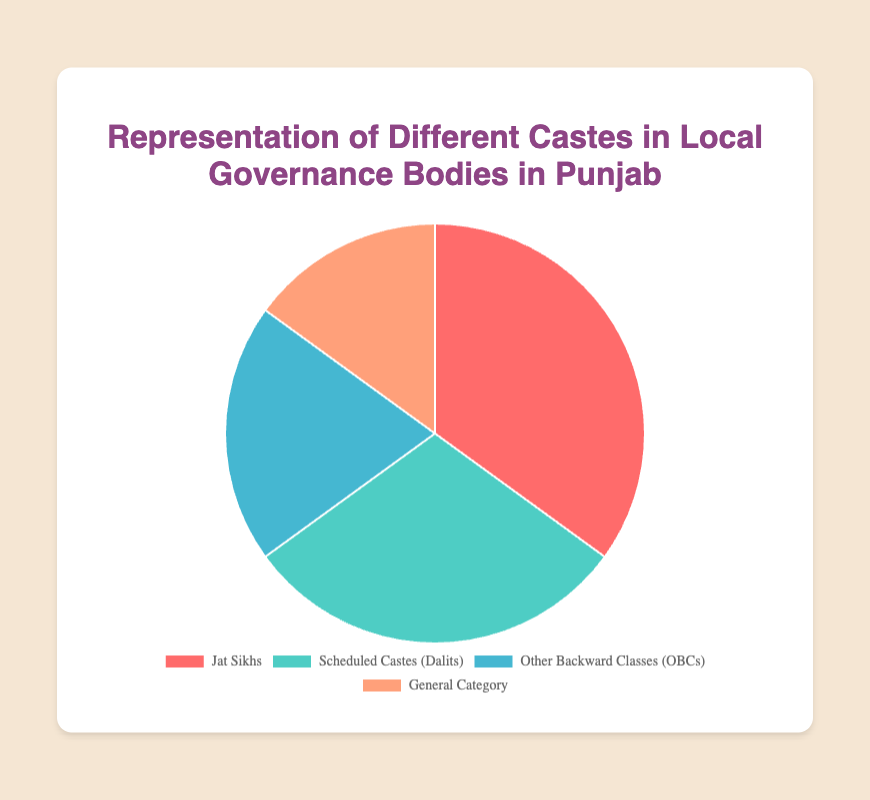What is the representation percentage of Scheduled Castes (Dalits) in local governance bodies? The figure shows that the representation of Scheduled Castes (Dalits) is 30%.
Answer: 30% Which caste has the highest representation in local governance bodies? The largest segment in the pie chart belongs to Jat Sikhs, indicating they have the highest representation.
Answer: Jat Sikhs What is the combined representation of Other Backward Classes (OBCs) and the General Category? The representation of OBCs is 20%, and the General Category is 15%. Summing these gives 20% + 15% = 35%.
Answer: 35% Which caste has the lowest representation, and what is that percentage? By observing the smallest segment in the pie chart, the General Category has the lowest representation at 15%.
Answer: General Category, 15% Is the representation of Scheduled Castes (Dalits) more or less than the combined representation of Other Backward Classes (OBCs) and General Category? The representation of Scheduled Castes (Dalits) is 30%, while the combined representation of OBCs and General Category is 35%, so it is less.
Answer: Less What is the difference in representation between Jat Sikhs and the General Category? Jat Sikhs have a representation of 35%, and the General Category has 15%. The difference is 35% - 15% = 20%.
Answer: 20% Which castes together make up more than half of the total representation? Jat Sikhs (35%) and Scheduled Castes (Dalits) (30%) together form 65%, which is more than half (50%) of the total representation.
Answer: Jat Sikhs and Scheduled Castes (Dalits) What percentage of total representation do Jat Sikhs and Scheduled Castes (Dalits) contribute together? Adding the representations of Jat Sikhs (35%) and Scheduled Castes (Dalits) (30%) gives 35% + 30% = 65%.
Answer: 65% Which caste group has a representation closest to one-third of the total? The Scheduled Castes (Dalits) have a 30% representation, which is closest to one-third (33.33%).
Answer: Scheduled Castes (Dalits) If you add the representation of Jat Sikhs and OBCs, what percentage remains for the other groups? Jat Sikhs have 35% and OBCs have 20%, totaling 55%. The remaining percentage is 100% - 55% = 45%.
Answer: 45% 